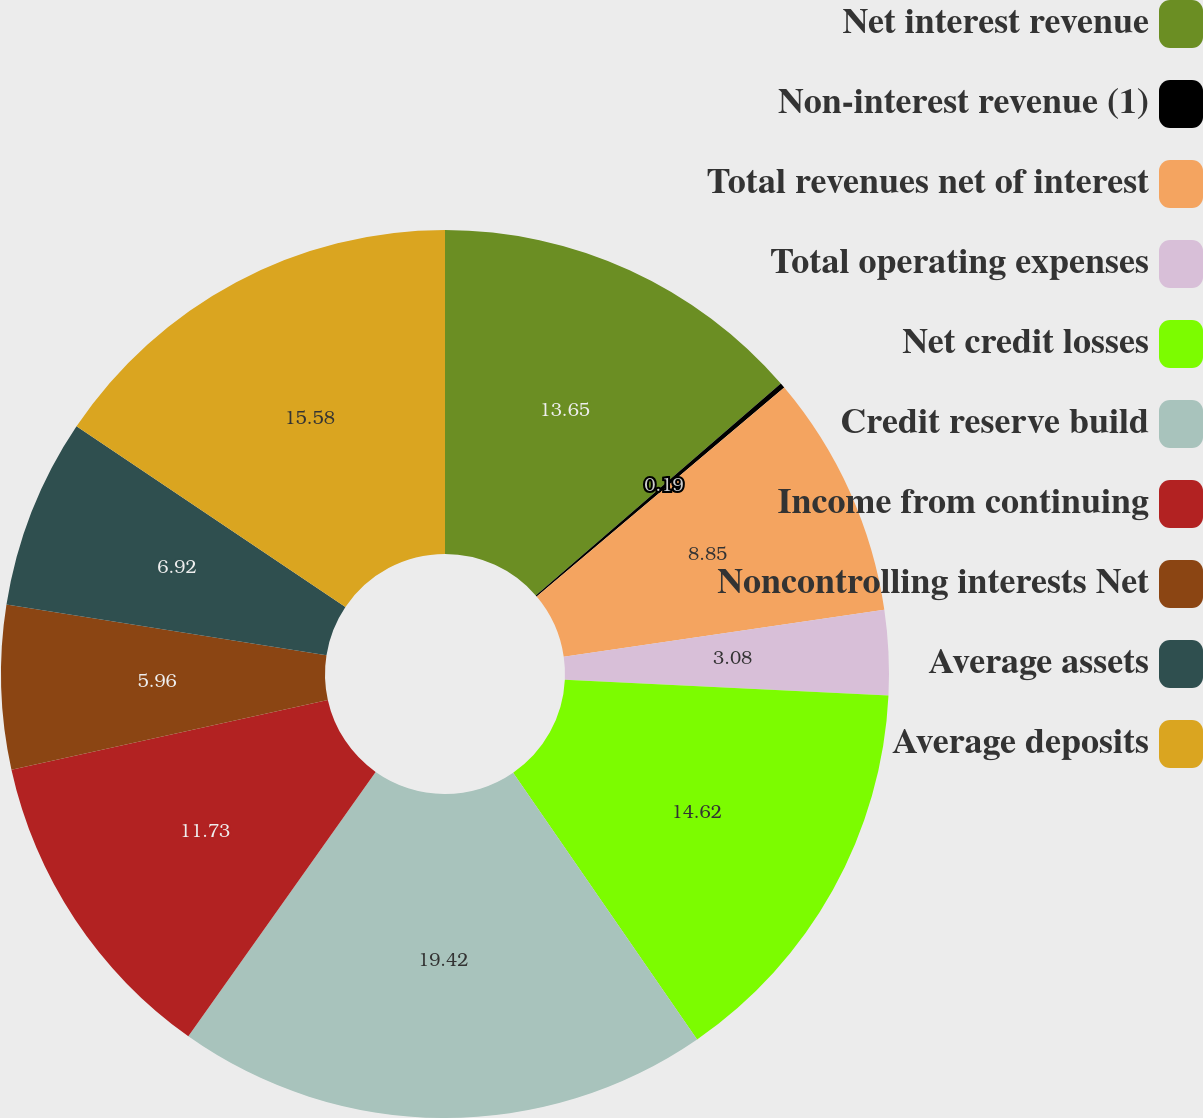<chart> <loc_0><loc_0><loc_500><loc_500><pie_chart><fcel>Net interest revenue<fcel>Non-interest revenue (1)<fcel>Total revenues net of interest<fcel>Total operating expenses<fcel>Net credit losses<fcel>Credit reserve build<fcel>Income from continuing<fcel>Noncontrolling interests Net<fcel>Average assets<fcel>Average deposits<nl><fcel>13.65%<fcel>0.19%<fcel>8.85%<fcel>3.08%<fcel>14.62%<fcel>19.42%<fcel>11.73%<fcel>5.96%<fcel>6.92%<fcel>15.58%<nl></chart> 